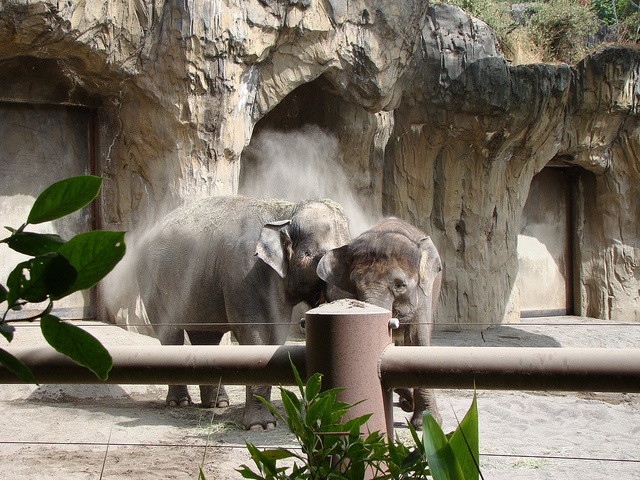Describe the objects in this image and their specific colors. I can see elephant in gray, black, darkgray, and lightgray tones and elephant in gray, darkgray, and black tones in this image. 